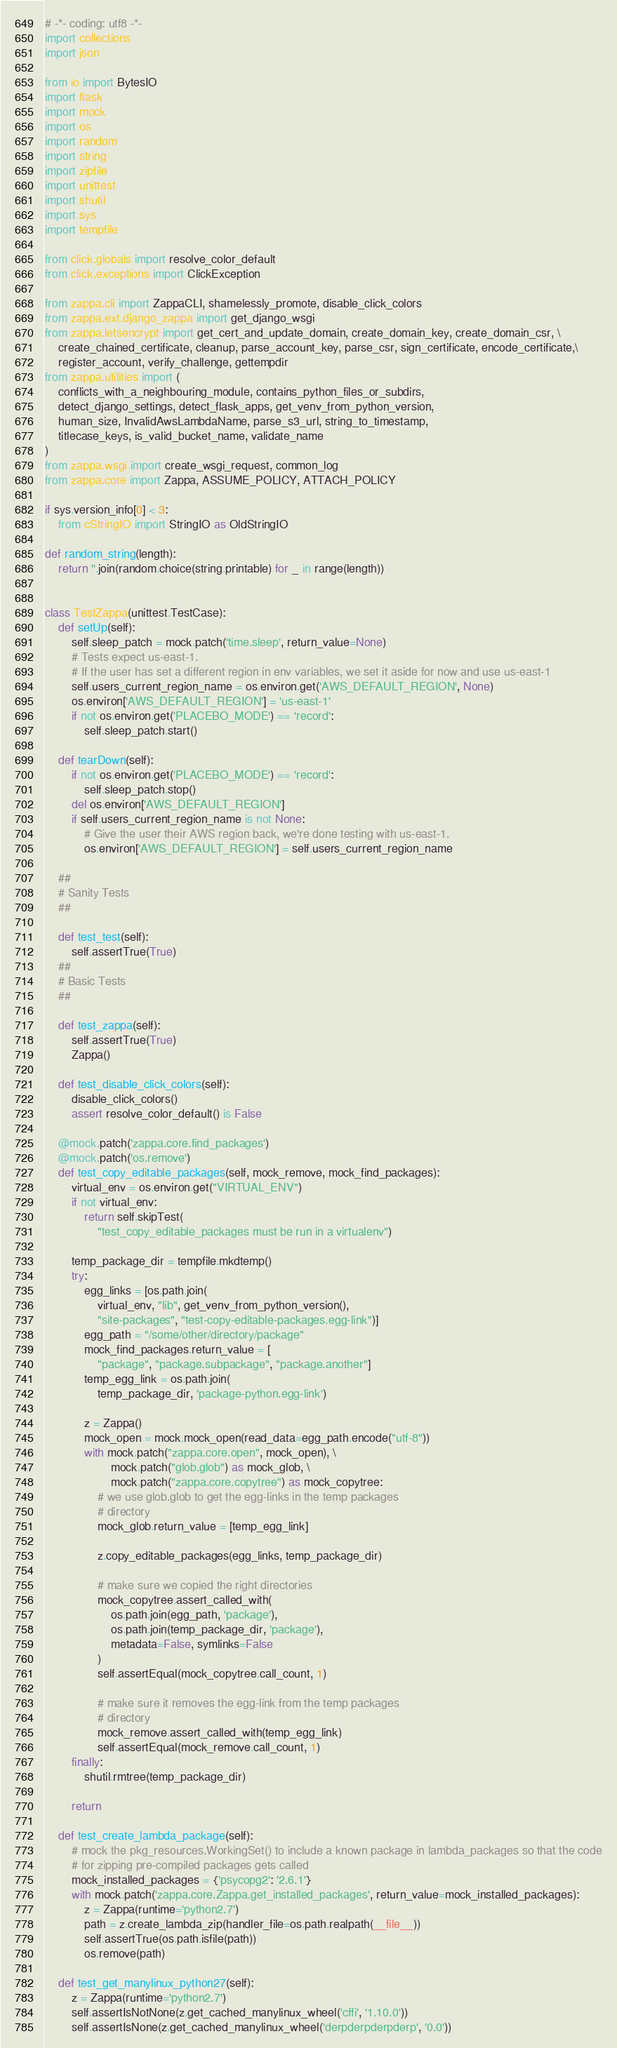<code> <loc_0><loc_0><loc_500><loc_500><_Python_># -*- coding: utf8 -*-
import collections
import json

from io import BytesIO
import flask
import mock
import os
import random
import string
import zipfile
import unittest
import shutil
import sys
import tempfile

from click.globals import resolve_color_default
from click.exceptions import ClickException

from zappa.cli import ZappaCLI, shamelessly_promote, disable_click_colors
from zappa.ext.django_zappa import get_django_wsgi
from zappa.letsencrypt import get_cert_and_update_domain, create_domain_key, create_domain_csr, \
    create_chained_certificate, cleanup, parse_account_key, parse_csr, sign_certificate, encode_certificate,\
    register_account, verify_challenge, gettempdir
from zappa.utilities import (
    conflicts_with_a_neighbouring_module, contains_python_files_or_subdirs,
    detect_django_settings, detect_flask_apps, get_venv_from_python_version,
    human_size, InvalidAwsLambdaName, parse_s3_url, string_to_timestamp,
    titlecase_keys, is_valid_bucket_name, validate_name
)
from zappa.wsgi import create_wsgi_request, common_log
from zappa.core import Zappa, ASSUME_POLICY, ATTACH_POLICY

if sys.version_info[0] < 3:
    from cStringIO import StringIO as OldStringIO

def random_string(length):
    return ''.join(random.choice(string.printable) for _ in range(length))


class TestZappa(unittest.TestCase):
    def setUp(self):
        self.sleep_patch = mock.patch('time.sleep', return_value=None)
        # Tests expect us-east-1.
        # If the user has set a different region in env variables, we set it aside for now and use us-east-1
        self.users_current_region_name = os.environ.get('AWS_DEFAULT_REGION', None)
        os.environ['AWS_DEFAULT_REGION'] = 'us-east-1'
        if not os.environ.get('PLACEBO_MODE') == 'record':
            self.sleep_patch.start()

    def tearDown(self):
        if not os.environ.get('PLACEBO_MODE') == 'record':
            self.sleep_patch.stop()
        del os.environ['AWS_DEFAULT_REGION']
        if self.users_current_region_name is not None:
            # Give the user their AWS region back, we're done testing with us-east-1.
            os.environ['AWS_DEFAULT_REGION'] = self.users_current_region_name

    ##
    # Sanity Tests
    ##

    def test_test(self):
        self.assertTrue(True)
    ##
    # Basic Tests
    ##

    def test_zappa(self):
        self.assertTrue(True)
        Zappa()

    def test_disable_click_colors(self):
        disable_click_colors()
        assert resolve_color_default() is False

    @mock.patch('zappa.core.find_packages')
    @mock.patch('os.remove')
    def test_copy_editable_packages(self, mock_remove, mock_find_packages):
        virtual_env = os.environ.get("VIRTUAL_ENV")
        if not virtual_env:
            return self.skipTest(
                "test_copy_editable_packages must be run in a virtualenv")

        temp_package_dir = tempfile.mkdtemp()
        try:
            egg_links = [os.path.join(
                virtual_env, "lib", get_venv_from_python_version(),
                "site-packages", "test-copy-editable-packages.egg-link")]
            egg_path = "/some/other/directory/package"
            mock_find_packages.return_value = [
                "package", "package.subpackage", "package.another"]
            temp_egg_link = os.path.join(
                temp_package_dir, 'package-python.egg-link')

            z = Zappa()
            mock_open = mock.mock_open(read_data=egg_path.encode("utf-8"))
            with mock.patch("zappa.core.open", mock_open), \
                    mock.patch("glob.glob") as mock_glob, \
                    mock.patch("zappa.core.copytree") as mock_copytree:
                # we use glob.glob to get the egg-links in the temp packages
                # directory
                mock_glob.return_value = [temp_egg_link]

                z.copy_editable_packages(egg_links, temp_package_dir)

                # make sure we copied the right directories
                mock_copytree.assert_called_with(
                    os.path.join(egg_path, 'package'),
                    os.path.join(temp_package_dir, 'package'),
                    metadata=False, symlinks=False
                )
                self.assertEqual(mock_copytree.call_count, 1)

                # make sure it removes the egg-link from the temp packages
                # directory
                mock_remove.assert_called_with(temp_egg_link)
                self.assertEqual(mock_remove.call_count, 1)
        finally:
            shutil.rmtree(temp_package_dir)

        return

    def test_create_lambda_package(self):
        # mock the pkg_resources.WorkingSet() to include a known package in lambda_packages so that the code
        # for zipping pre-compiled packages gets called
        mock_installed_packages = {'psycopg2': '2.6.1'}
        with mock.patch('zappa.core.Zappa.get_installed_packages', return_value=mock_installed_packages):
            z = Zappa(runtime='python2.7')
            path = z.create_lambda_zip(handler_file=os.path.realpath(__file__))
            self.assertTrue(os.path.isfile(path))
            os.remove(path)

    def test_get_manylinux_python27(self):
        z = Zappa(runtime='python2.7')
        self.assertIsNotNone(z.get_cached_manylinux_wheel('cffi', '1.10.0'))
        self.assertIsNone(z.get_cached_manylinux_wheel('derpderpderpderp', '0.0'))
</code> 